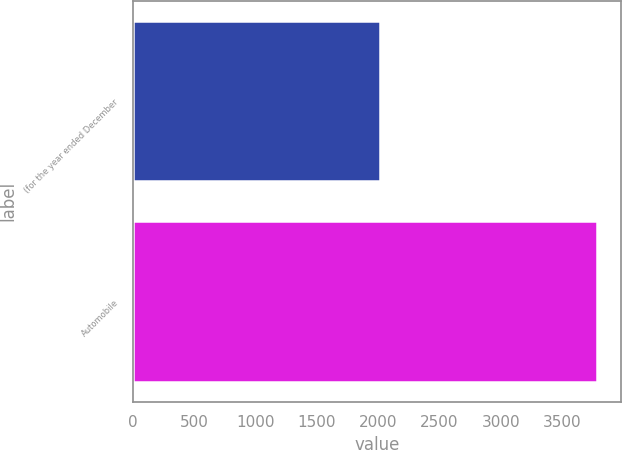<chart> <loc_0><loc_0><loc_500><loc_500><bar_chart><fcel>(for the year ended December<fcel>Automobile<nl><fcel>2011<fcel>3788<nl></chart> 